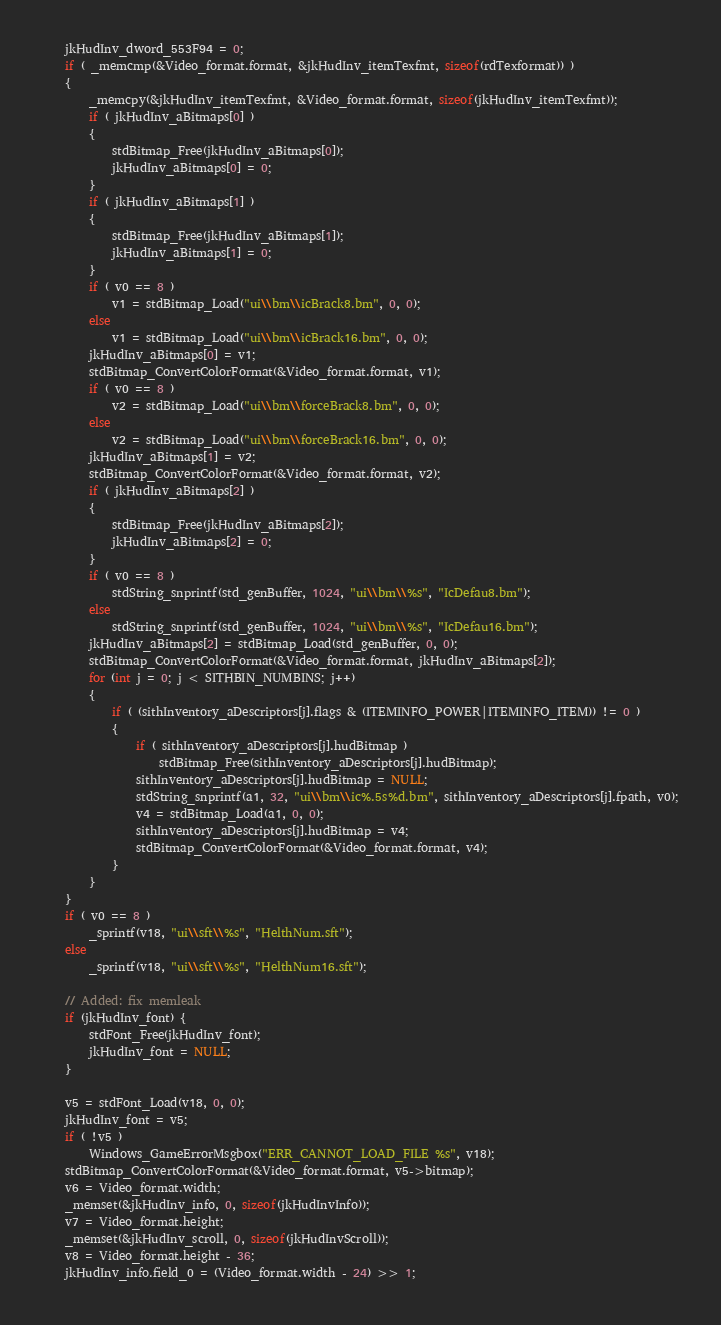<code> <loc_0><loc_0><loc_500><loc_500><_C_>    jkHudInv_dword_553F94 = 0;
    if ( _memcmp(&Video_format.format, &jkHudInv_itemTexfmt, sizeof(rdTexformat)) )
    {
        _memcpy(&jkHudInv_itemTexfmt, &Video_format.format, sizeof(jkHudInv_itemTexfmt));
        if ( jkHudInv_aBitmaps[0] )
        {
            stdBitmap_Free(jkHudInv_aBitmaps[0]);
            jkHudInv_aBitmaps[0] = 0;
        }
        if ( jkHudInv_aBitmaps[1] )
        {
            stdBitmap_Free(jkHudInv_aBitmaps[1]);
            jkHudInv_aBitmaps[1] = 0;
        }
        if ( v0 == 8 )
            v1 = stdBitmap_Load("ui\\bm\\icBrack8.bm", 0, 0);
        else
            v1 = stdBitmap_Load("ui\\bm\\icBrack16.bm", 0, 0);
        jkHudInv_aBitmaps[0] = v1;
        stdBitmap_ConvertColorFormat(&Video_format.format, v1);
        if ( v0 == 8 )
            v2 = stdBitmap_Load("ui\\bm\\forceBrack8.bm", 0, 0);
        else
            v2 = stdBitmap_Load("ui\\bm\\forceBrack16.bm", 0, 0);
        jkHudInv_aBitmaps[1] = v2;
        stdBitmap_ConvertColorFormat(&Video_format.format, v2);
        if ( jkHudInv_aBitmaps[2] )
        {
            stdBitmap_Free(jkHudInv_aBitmaps[2]);
            jkHudInv_aBitmaps[2] = 0;
        }
        if ( v0 == 8 )
            stdString_snprintf(std_genBuffer, 1024, "ui\\bm\\%s", "IcDefau8.bm");
        else
            stdString_snprintf(std_genBuffer, 1024, "ui\\bm\\%s", "IcDefau16.bm");
        jkHudInv_aBitmaps[2] = stdBitmap_Load(std_genBuffer, 0, 0);
        stdBitmap_ConvertColorFormat(&Video_format.format, jkHudInv_aBitmaps[2]);
        for (int j = 0; j < SITHBIN_NUMBINS; j++)
        {
            if ( (sithInventory_aDescriptors[j].flags & (ITEMINFO_POWER|ITEMINFO_ITEM)) != 0 )
            {
                if ( sithInventory_aDescriptors[j].hudBitmap )
                    stdBitmap_Free(sithInventory_aDescriptors[j].hudBitmap);
                sithInventory_aDescriptors[j].hudBitmap = NULL;
                stdString_snprintf(a1, 32, "ui\\bm\\ic%.5s%d.bm", sithInventory_aDescriptors[j].fpath, v0);
                v4 = stdBitmap_Load(a1, 0, 0);
                sithInventory_aDescriptors[j].hudBitmap = v4;
                stdBitmap_ConvertColorFormat(&Video_format.format, v4);
            }
        }
    }
    if ( v0 == 8 )
        _sprintf(v18, "ui\\sft\\%s", "HelthNum.sft");
    else
        _sprintf(v18, "ui\\sft\\%s", "HelthNum16.sft");
    
    // Added: fix memleak
    if (jkHudInv_font) {
        stdFont_Free(jkHudInv_font);
        jkHudInv_font = NULL;
    }

    v5 = stdFont_Load(v18, 0, 0);
    jkHudInv_font = v5;
    if ( !v5 )
        Windows_GameErrorMsgbox("ERR_CANNOT_LOAD_FILE %s", v18);
    stdBitmap_ConvertColorFormat(&Video_format.format, v5->bitmap);
    v6 = Video_format.width;
    _memset(&jkHudInv_info, 0, sizeof(jkHudInvInfo));
    v7 = Video_format.height;
    _memset(&jkHudInv_scroll, 0, sizeof(jkHudInvScroll));
    v8 = Video_format.height - 36;
    jkHudInv_info.field_0 = (Video_format.width - 24) >> 1;</code> 